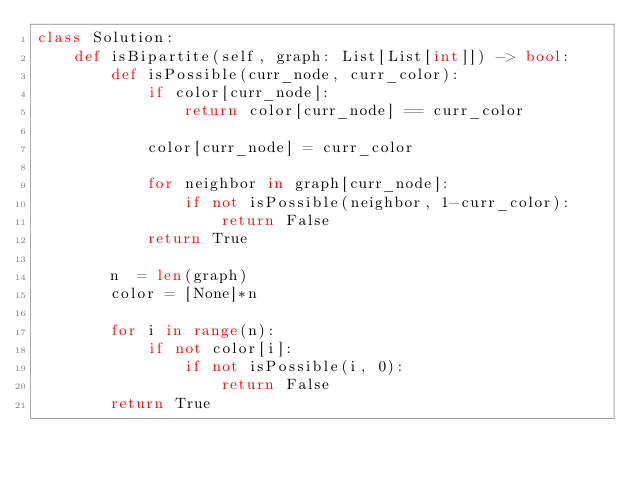<code> <loc_0><loc_0><loc_500><loc_500><_Python_>class Solution:
    def isBipartite(self, graph: List[List[int]]) -> bool:
        def isPossible(curr_node, curr_color):
            if color[curr_node]:
                return color[curr_node] == curr_color
            
            color[curr_node] = curr_color
            
            for neighbor in graph[curr_node]:
                if not isPossible(neighbor, 1-curr_color):
                    return False
            return True
                
        n  = len(graph)
        color = [None]*n
        
        for i in range(n):
            if not color[i]:
                if not isPossible(i, 0):
                    return False
        return True
</code> 